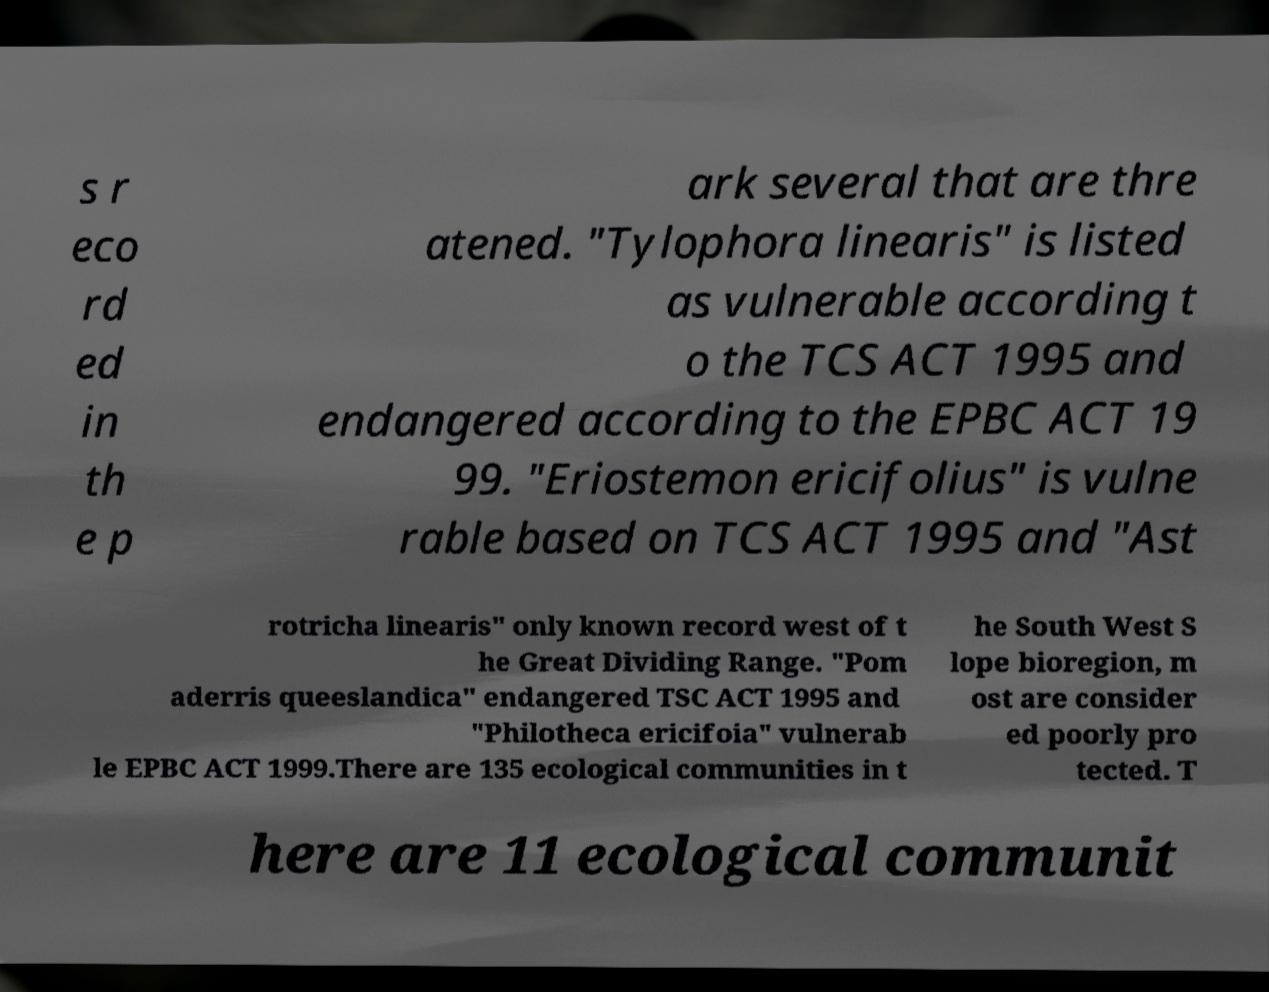Could you extract and type out the text from this image? s r eco rd ed in th e p ark several that are thre atened. "Tylophora linearis" is listed as vulnerable according t o the TCS ACT 1995 and endangered according to the EPBC ACT 19 99. "Eriostemon ericifolius" is vulne rable based on TCS ACT 1995 and "Ast rotricha linearis" only known record west of t he Great Dividing Range. "Pom aderris queeslandica" endangered TSC ACT 1995 and "Philotheca ericifoia" vulnerab le EPBC ACT 1999.There are 135 ecological communities in t he South West S lope bioregion, m ost are consider ed poorly pro tected. T here are 11 ecological communit 